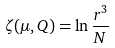Convert formula to latex. <formula><loc_0><loc_0><loc_500><loc_500>\zeta ( \mu , Q ) = \ln \frac { r ^ { 3 } } N</formula> 